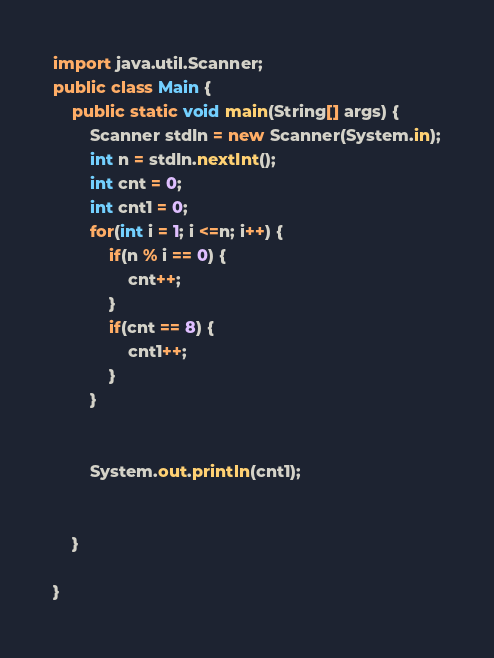Convert code to text. <code><loc_0><loc_0><loc_500><loc_500><_Java_>import java.util.Scanner;
public class Main {
	public static void main(String[] args) {
		Scanner stdIn = new Scanner(System.in);
		int n = stdIn.nextInt();
		int cnt = 0;
		int cnt1 = 0;
		for(int i = 1; i <=n; i++) {
			if(n % i == 0) {
				cnt++;
			}
			if(cnt == 8) {
				cnt1++;
			}
		}
		
		
		System.out.println(cnt1);
		
		
	}

}
</code> 